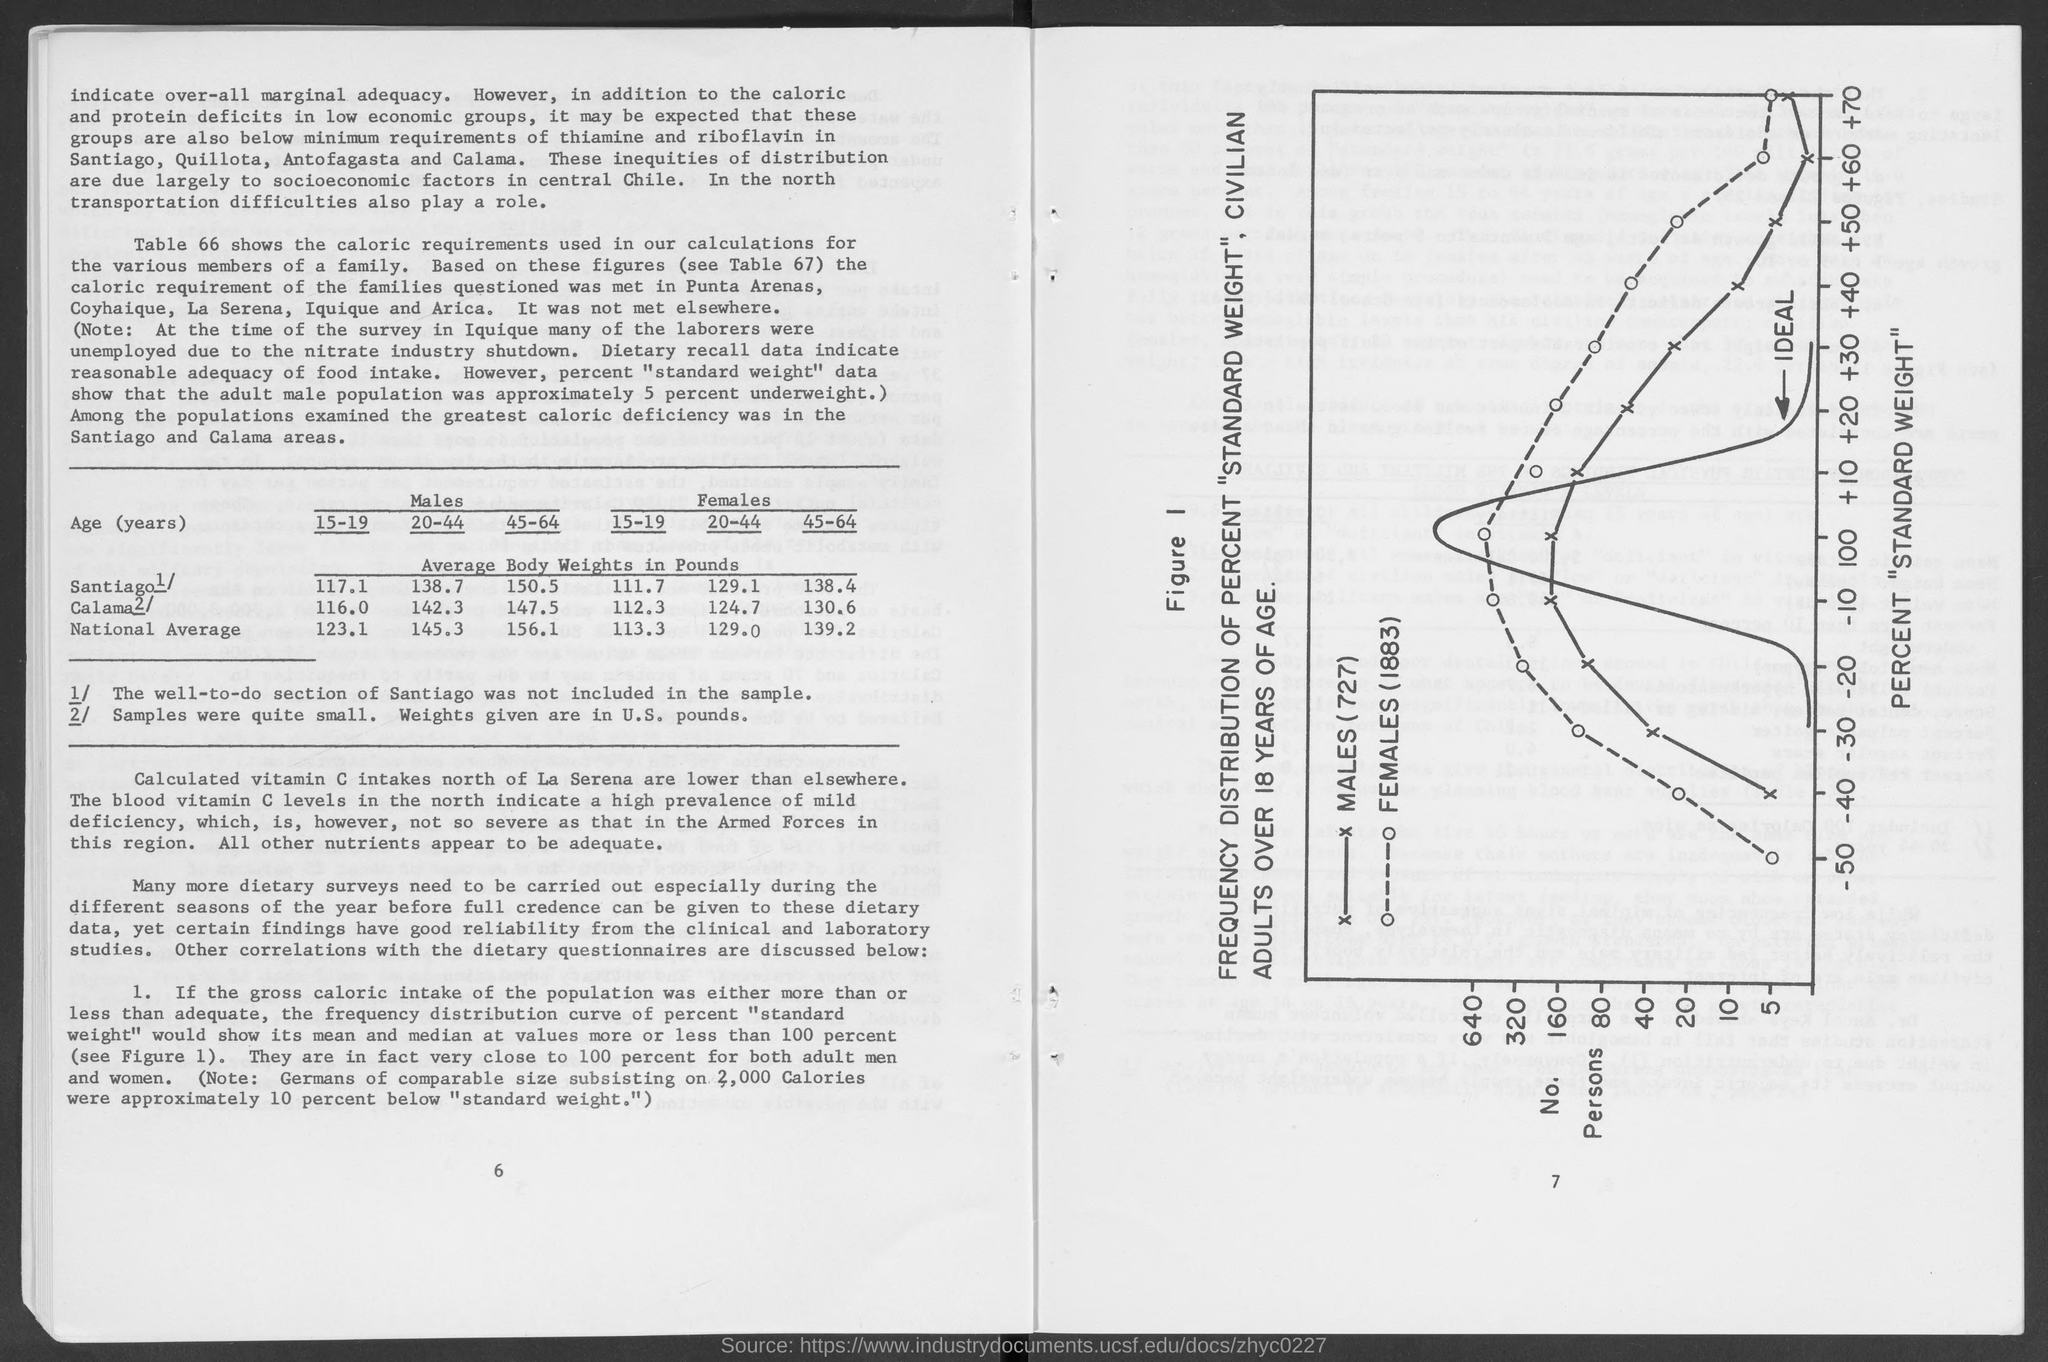Outline some significant characteristics in this image. According to the national average, the weight of females aged 45-64 is 139.2 pounds. The study examined the areas of Santiago and Calama to determine which areas had the greatest caloric deficiency in the population. The unit of weights given in the table is pounds. 